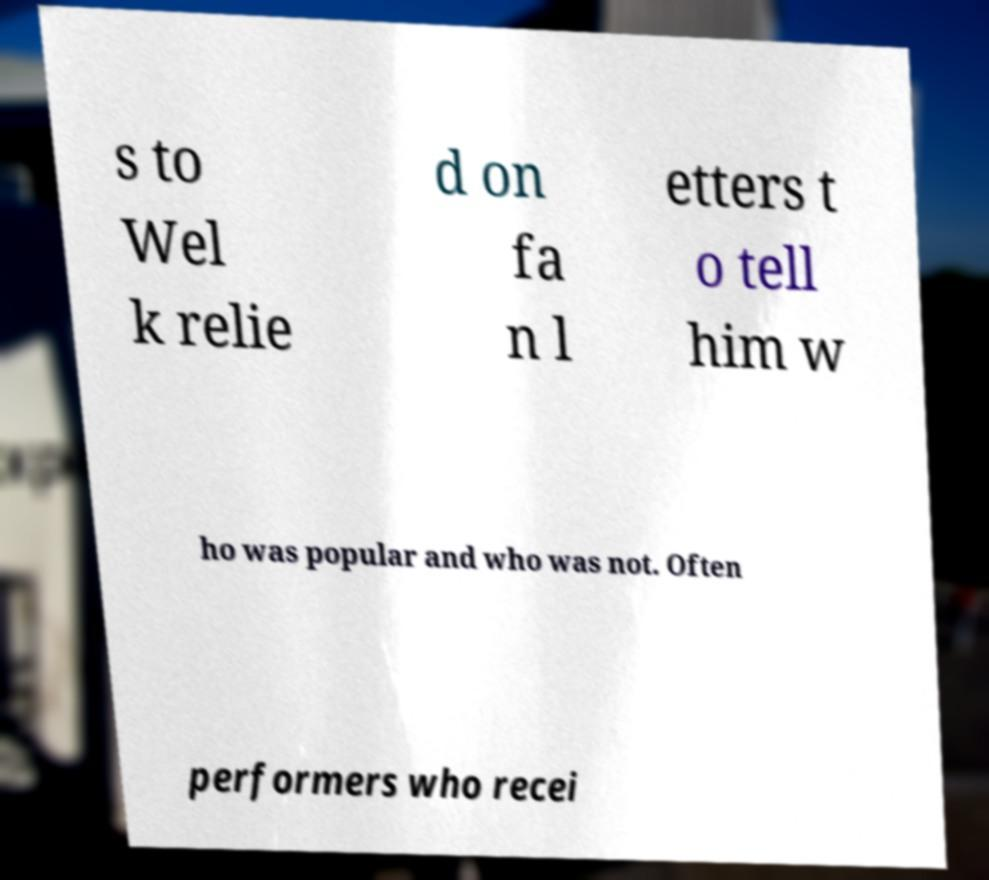Can you accurately transcribe the text from the provided image for me? s to Wel k relie d on fa n l etters t o tell him w ho was popular and who was not. Often performers who recei 